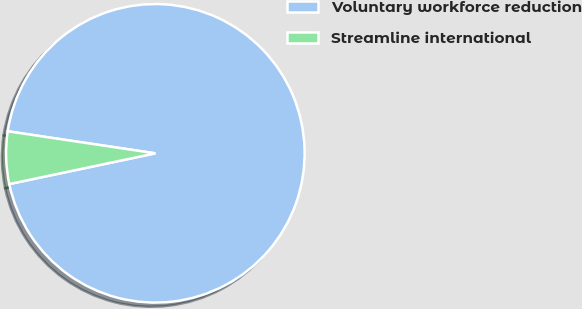<chart> <loc_0><loc_0><loc_500><loc_500><pie_chart><fcel>Voluntary workforce reduction<fcel>Streamline international<nl><fcel>94.34%<fcel>5.66%<nl></chart> 